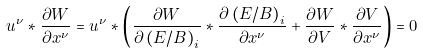<formula> <loc_0><loc_0><loc_500><loc_500>u ^ { \nu } * \frac { \partial W } { \partial x ^ { \nu } } = u ^ { \nu } * \left ( \frac { \partial W } { \partial \left ( E / B \right ) _ { i } } * \frac { \partial \left ( E / B \right ) _ { i } } { \partial x ^ { \nu } } + \frac { \partial W } { \partial V } * \frac { \partial V } { \partial x ^ { \nu } } \right ) = 0</formula> 